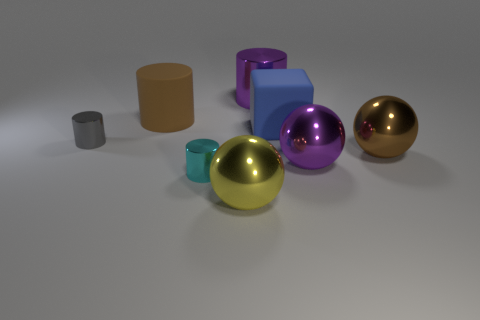There is a metal thing that is left of the large brown cylinder; what is its size?
Provide a short and direct response. Small. How many big things are yellow metallic cubes or cyan cylinders?
Your response must be concise. 0. What is the color of the cylinder that is both behind the gray shiny cylinder and left of the cyan cylinder?
Give a very brief answer. Brown. Are there any brown shiny things that have the same shape as the big yellow metal thing?
Your answer should be compact. Yes. What is the material of the big brown cylinder?
Keep it short and to the point. Rubber. Are there any brown objects in front of the rubber cube?
Give a very brief answer. Yes. Do the small gray shiny object and the yellow thing have the same shape?
Ensure brevity in your answer.  No. What number of other things are there of the same size as the yellow metallic ball?
Keep it short and to the point. 5. How many things are big brown things to the right of the cyan metallic cylinder or large blue spheres?
Your answer should be compact. 1. The big shiny cylinder has what color?
Provide a succinct answer. Purple. 